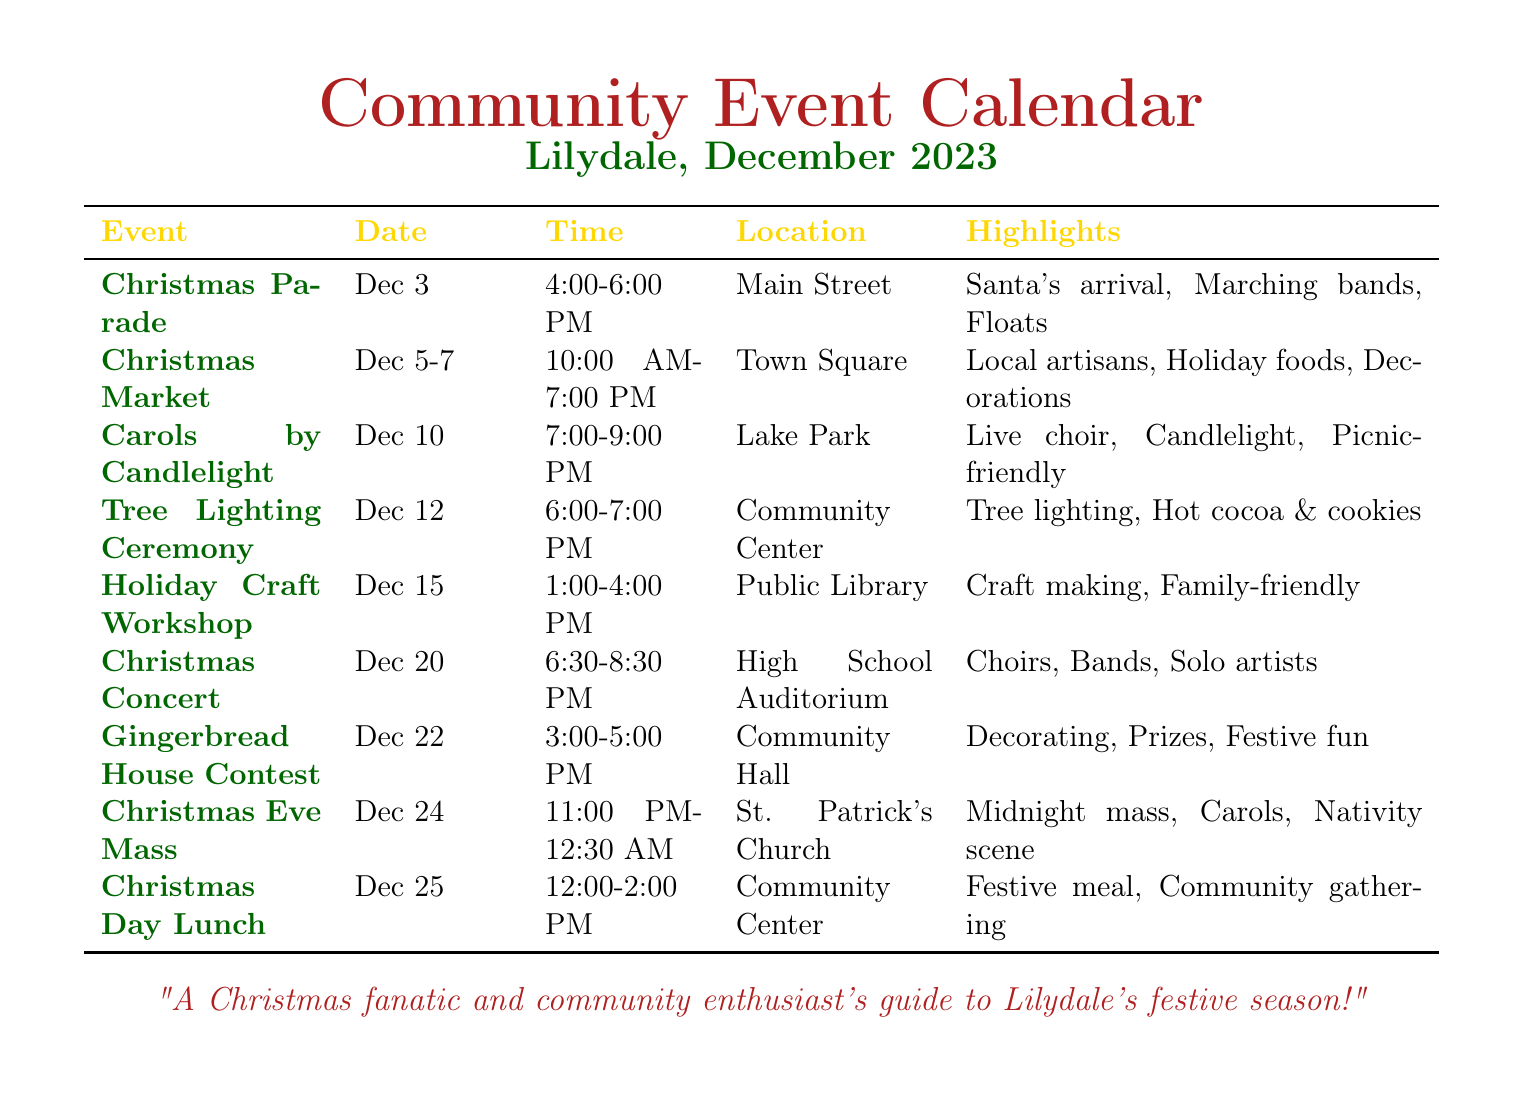What date is the Christmas Parade scheduled for? The Christmas Parade is listed on December 3 in the document.
Answer: December 3 What time does the Christmas Market start? The Christmas Market starts at 10:00 AM on December 5-7 according to the schedule.
Answer: 10:00 AM Where is the Tree Lighting Ceremony taking place? The location of the Tree Lighting Ceremony is the Community Center as specified in the document.
Answer: Community Center How long is the Carols by Candlelight event? The event runs for 2 hours, from 7:00 to 9:00 PM on December 10.
Answer: 2 hours What activity will take place during the Gingerbread House Contest? The document highlights "decorating" as the main activity for this contest.
Answer: Decorating Which event occurs on Christmas Eve? The event happening on Christmas Eve is called Christmas Eve Mass as mentioned in the calendar.
Answer: Christmas Eve Mass How many days will the Christmas Market be open? The Christmas Market is open over three days: December 5, 6, and 7 according to the data.
Answer: 3 days What type of crowd can attend the Holiday Craft Workshop? The workshop is described as "family-friendly," indicating it is suitable for all ages.
Answer: Family-friendly What food is served at the Christmas Day Lunch? The document mentions a "festive meal" is served during the Christmas Day Lunch.
Answer: Festive meal 